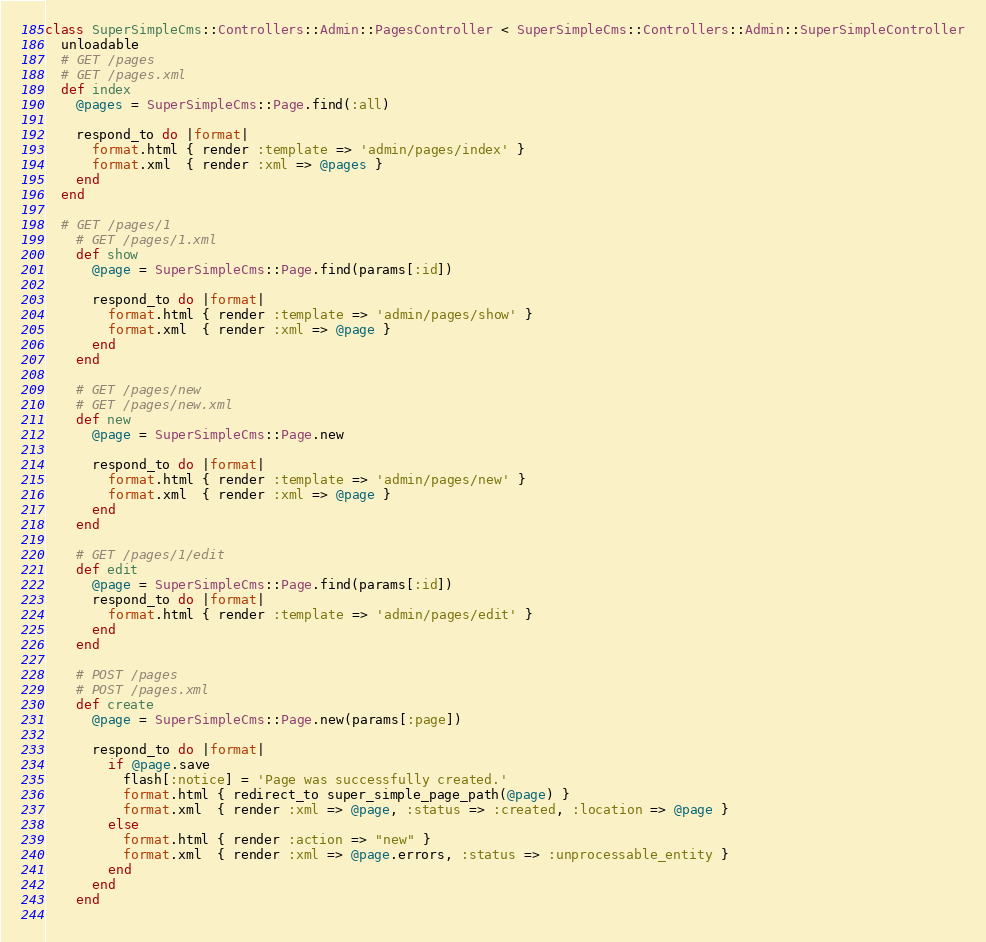Convert code to text. <code><loc_0><loc_0><loc_500><loc_500><_Ruby_>class SuperSimpleCms::Controllers::Admin::PagesController < SuperSimpleCms::Controllers::Admin::SuperSimpleController
  unloadable
  # GET /pages
  # GET /pages.xml
  def index
    @pages = SuperSimpleCms::Page.find(:all)

    respond_to do |format|
      format.html { render :template => 'admin/pages/index' }
      format.xml  { render :xml => @pages }
    end
  end

  # GET /pages/1
    # GET /pages/1.xml
    def show
      @page = SuperSimpleCms::Page.find(params[:id])
    
      respond_to do |format|
        format.html { render :template => 'admin/pages/show' }
        format.xml  { render :xml => @page }
      end
    end
    
    # GET /pages/new
    # GET /pages/new.xml
    def new
      @page = SuperSimpleCms::Page.new
    
      respond_to do |format|
        format.html { render :template => 'admin/pages/new' }
        format.xml  { render :xml => @page }
      end
    end
    
    # GET /pages/1/edit
    def edit
      @page = SuperSimpleCms::Page.find(params[:id])
      respond_to do |format|
        format.html { render :template => 'admin/pages/edit' }
      end
    end
    
    # POST /pages
    # POST /pages.xml
    def create
      @page = SuperSimpleCms::Page.new(params[:page])
    
      respond_to do |format|
        if @page.save
          flash[:notice] = 'Page was successfully created.'
          format.html { redirect_to super_simple_page_path(@page) }
          format.xml  { render :xml => @page, :status => :created, :location => @page }
        else
          format.html { render :action => "new" }
          format.xml  { render :xml => @page.errors, :status => :unprocessable_entity }
        end
      end
    end
    </code> 